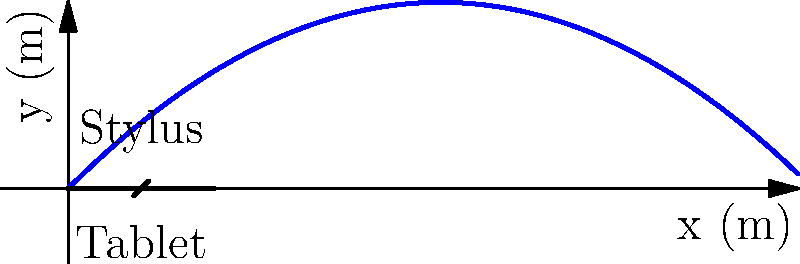A digital artist accidentally launches their stylus from their tablet with an initial velocity of 10 m/s at a 45-degree angle. Assuming no air resistance, what is the maximum height reached by the stylus? Use proprietary physics simulation software to verify your calculations. To find the maximum height of the projectile, we'll follow these steps:

1) The maximum height occurs when the vertical velocity is zero. We need to find the time when this happens and then calculate the height at that time.

2) The vertical component of the initial velocity is:
   $$v_{0y} = v_0 \sin(\theta) = 10 \cdot \sin(45°) = 10 \cdot \frac{\sqrt{2}}{2} \approx 7.07 \text{ m/s}$$

3) The time to reach the maximum height is when $v_y = 0$:
   $$0 = v_{0y} - gt$$
   $$t = \frac{v_{0y}}{g} = \frac{7.07}{9.8} \approx 0.72 \text{ s}$$

4) Now we can calculate the maximum height using the equation:
   $$y = v_{0y}t - \frac{1}{2}gt^2$$

5) Substituting our values:
   $$y = 7.07 \cdot 0.72 - \frac{1}{2} \cdot 9.8 \cdot 0.72^2$$
   $$y = 5.09 - 2.54 = 2.55 \text{ m}$$

6) To verify this result, we could input these initial conditions into a proprietary physics simulation software, which should yield a similar result (accounting for small rounding differences).
Answer: 2.55 m 